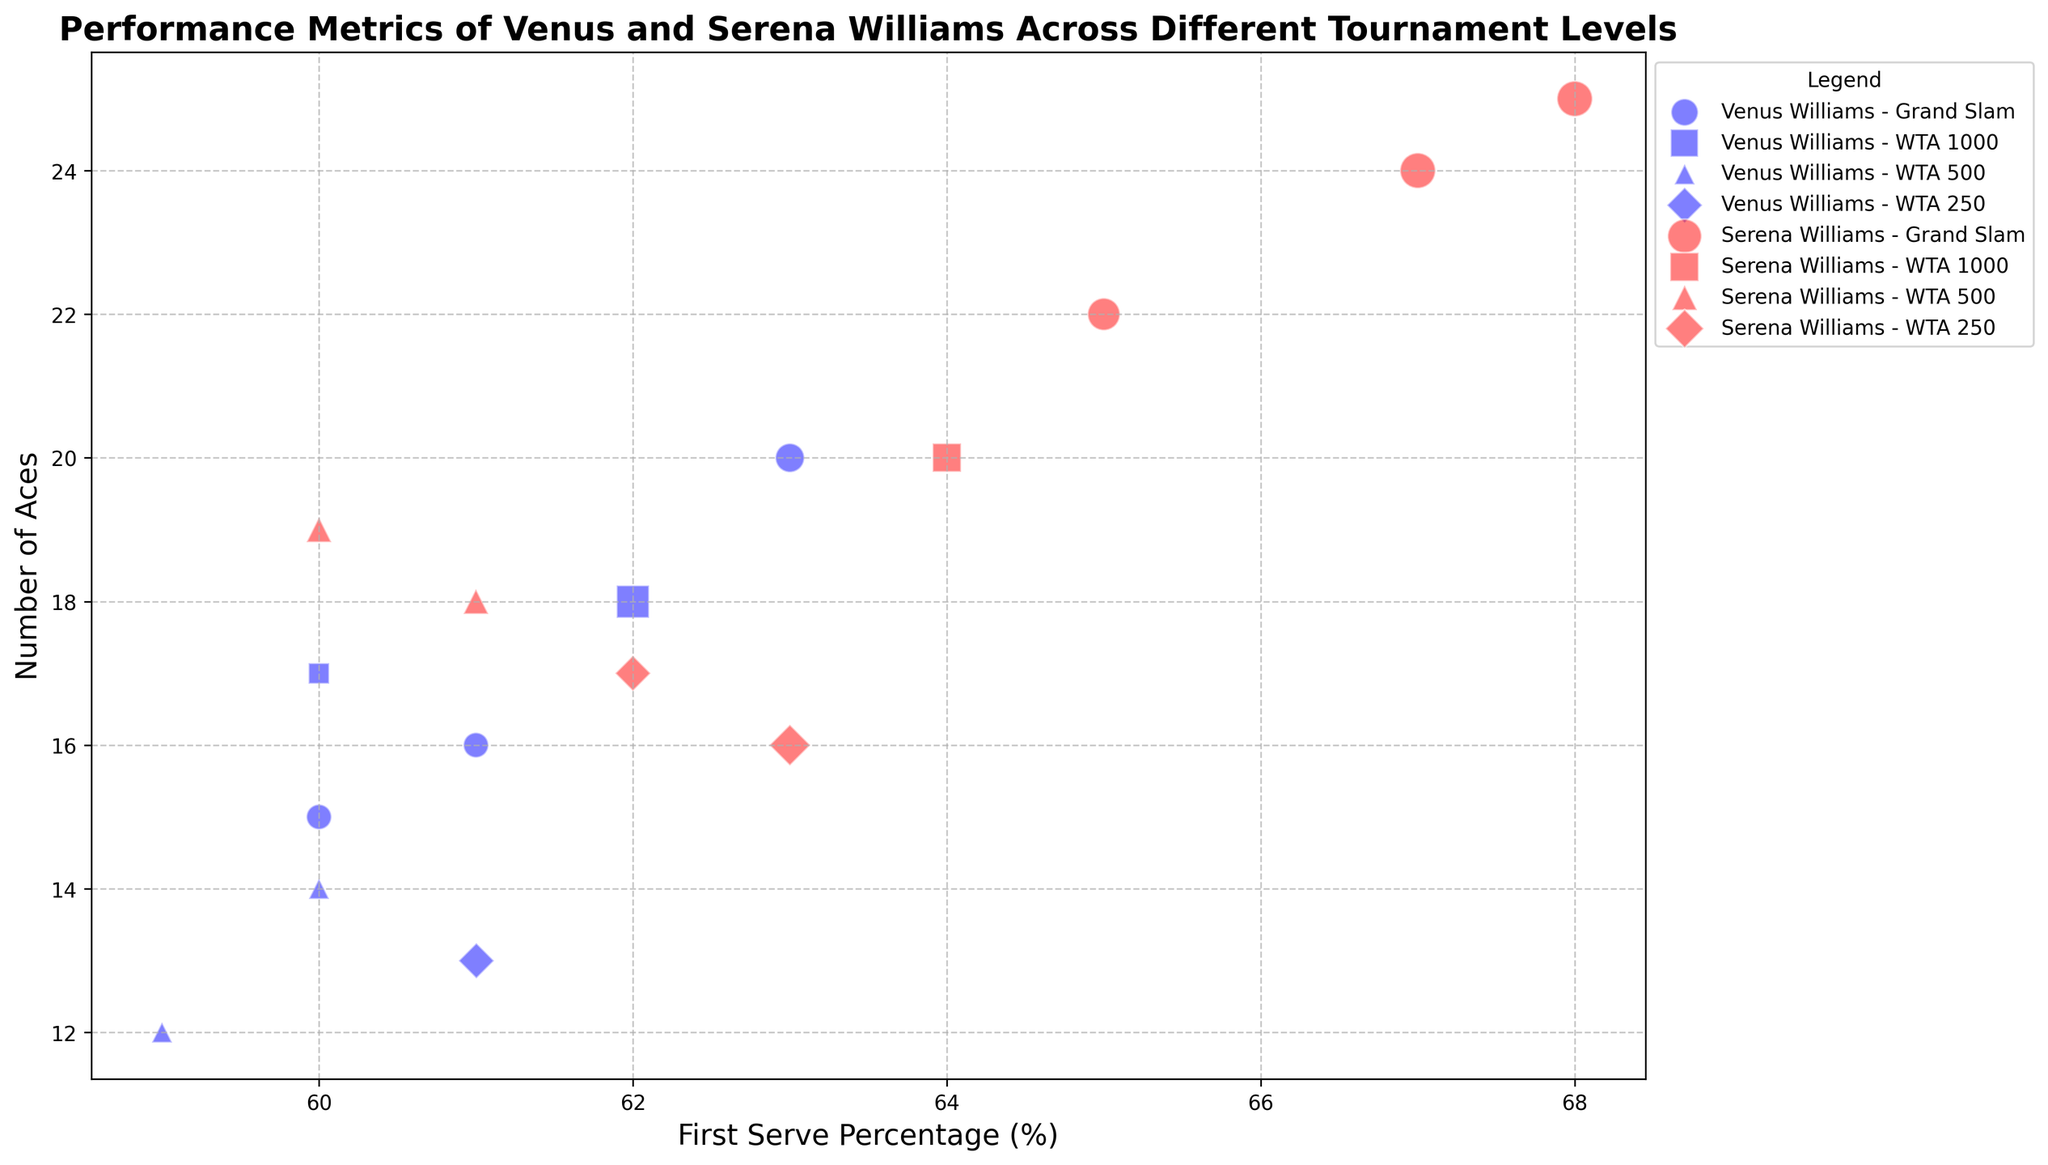What is the First Serve Percentage range for Serena Williams at Grand Slam level tournaments? To determine this, look at the horizontal axis values for the red circles (indicating Serena Williams) and circular marker shapes (indicating Grand Slam level). The First Serve Percentage values range from 65% to 68%.
Answer: 65% to 68% Which player has a higher number of Aces in Grand Slam tournaments, Venus or Serena Williams? Look at the vertical axis for the blue (Venus) and red (Serena) circular markers. Serena Williams consistently has a higher number of Aces in these tournaments.
Answer: Serena Williams Compare Venus and Serena Williams' First Serve Percentage in WTA 1000 tournaments. Who has the greater First Serve Percentage? Focus on the blue (Venus) and red (Serena) square markers. Venus has First Serve Percentage values of 60%, 62%, and 62%, while Serena's are all at 64%.
Answer: Serena Williams How do the Match Wins of Venus and Serena Williams in WTA 250 tournaments compare? Refer to the size of the blue (Venus) and red (Serena) diamond markers. Venus has Match Wins represented by marker sizes corresponding to 3, while Serena's markers represent 3 and 4 Match Wins.
Answer: Serena Williams What Tournament Level seems to have the highest Aces for Venus Williams? Look at the height on the vertical axis for the blue markers (Venus) across the different shapes (Tournament Levels). Venus has the highest Aces in a WTA 1000 tournament, indicated by a square marker.
Answer: WTA 1000 In which Tournament Level does Serena Williams have the highest First Serve Percentage? Look at the horizontal axis for the red markers (Serena) and note the highest value among the different shapes. The highest First Serve Percentage for Serena, 68%, appears in a Grand Slam (circular marker).
Answer: Grand Slam What is the maximum number of Aces for Serena Williams across all Tournament Levels? Examine the red markers across all shapes and note the highest vertical position. Serena's maximum Aces count is 25 in a Grand Slam tournament.
Answer: 25 Which player has a higher First Serve Percentage in WTA 500 tournaments and by how much? Compare the horizontal positions of Venus' (blue triangles) and Serena's (red triangles) markers. Serena's First Serve Percentage is 61%, while Venus' is 59% and 60%, making Serena's value higher by 1% at 61%.
Answer: Serena by 1% Do Venus and Serena Williams have any Tournament Levels with identical First Serve Percentage? If so, which? Look for markers from both players that align on the horizontal axis. Both Venus (blue diamond) and Serena (red diamond) have markers at 63%, seen in WTA 250 tournaments.
Answer: Yes, WTA 250 